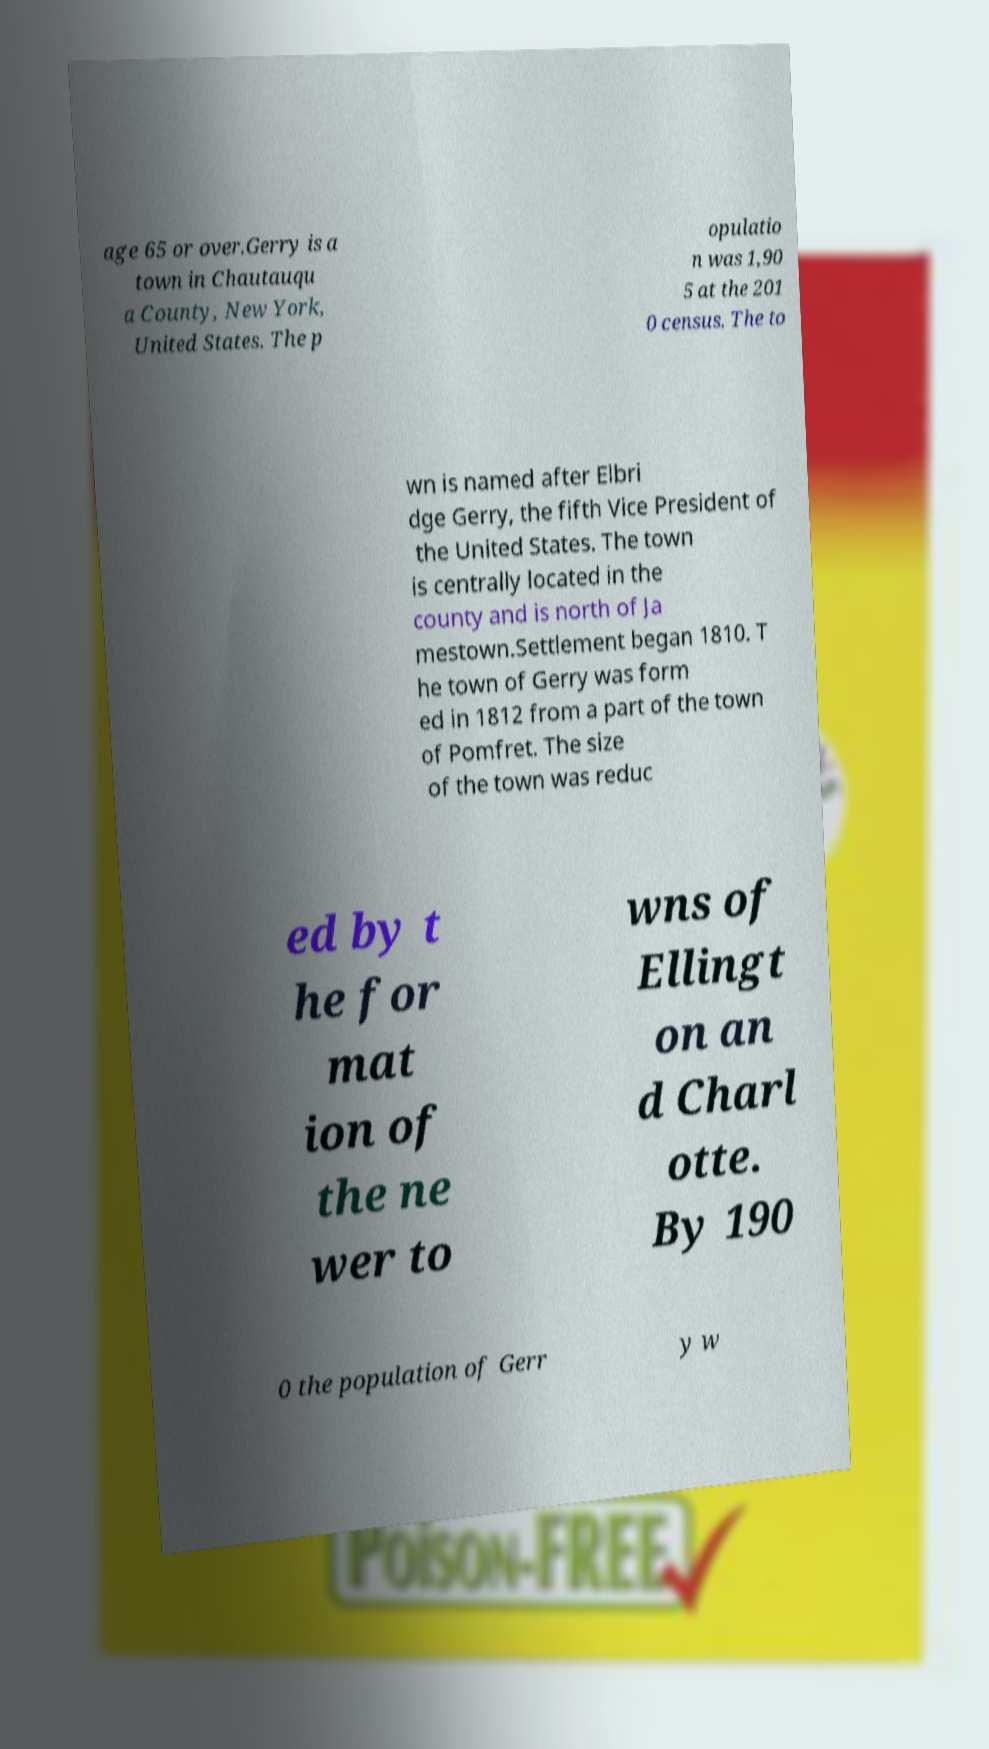Can you read and provide the text displayed in the image?This photo seems to have some interesting text. Can you extract and type it out for me? age 65 or over.Gerry is a town in Chautauqu a County, New York, United States. The p opulatio n was 1,90 5 at the 201 0 census. The to wn is named after Elbri dge Gerry, the fifth Vice President of the United States. The town is centrally located in the county and is north of Ja mestown.Settlement began 1810. T he town of Gerry was form ed in 1812 from a part of the town of Pomfret. The size of the town was reduc ed by t he for mat ion of the ne wer to wns of Ellingt on an d Charl otte. By 190 0 the population of Gerr y w 